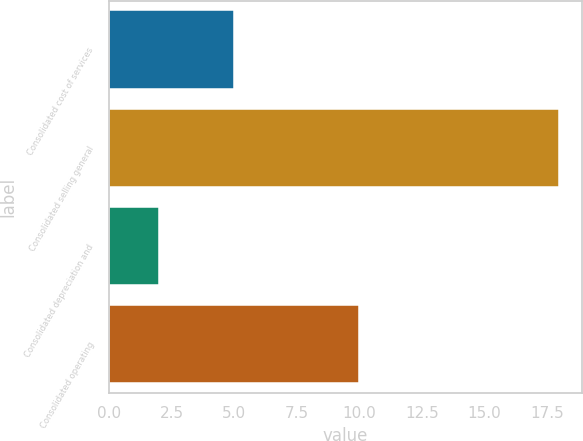Convert chart. <chart><loc_0><loc_0><loc_500><loc_500><bar_chart><fcel>Consolidated cost of services<fcel>Consolidated selling general<fcel>Consolidated depreciation and<fcel>Consolidated operating<nl><fcel>5<fcel>18<fcel>2<fcel>10<nl></chart> 